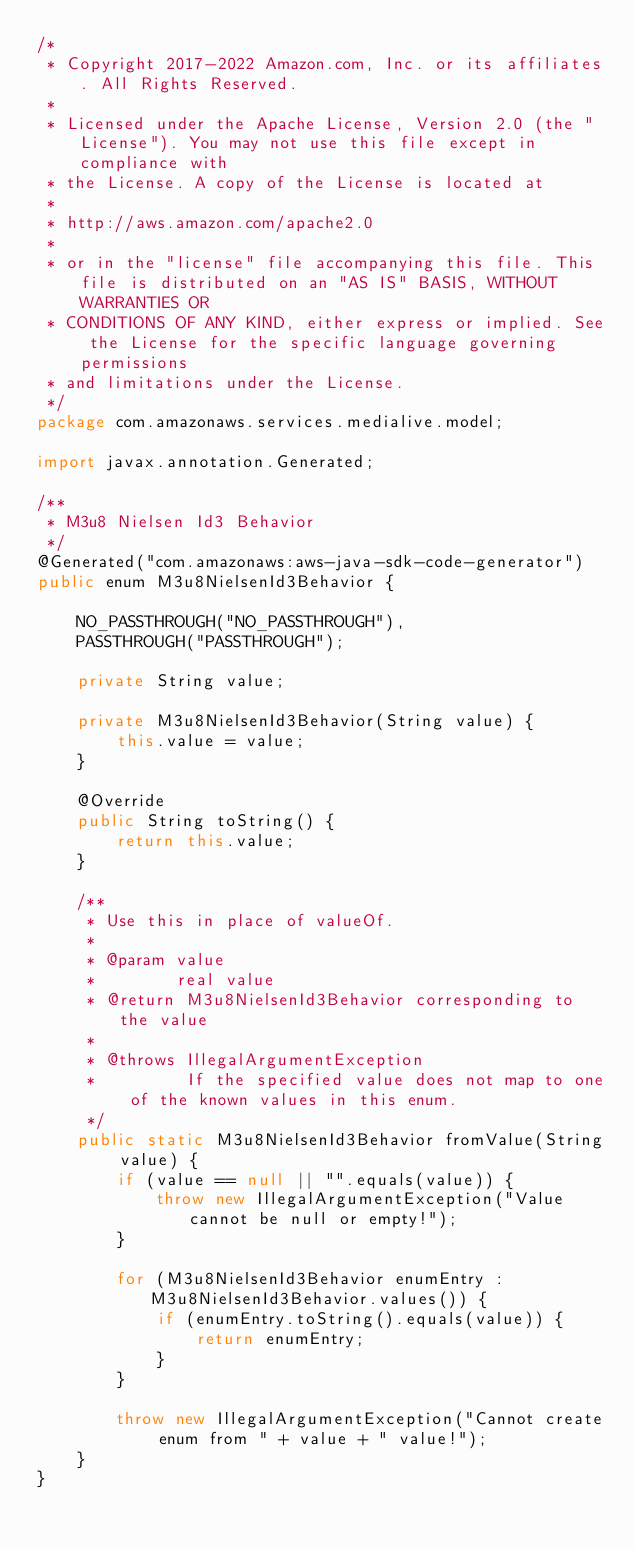<code> <loc_0><loc_0><loc_500><loc_500><_Java_>/*
 * Copyright 2017-2022 Amazon.com, Inc. or its affiliates. All Rights Reserved.
 * 
 * Licensed under the Apache License, Version 2.0 (the "License"). You may not use this file except in compliance with
 * the License. A copy of the License is located at
 * 
 * http://aws.amazon.com/apache2.0
 * 
 * or in the "license" file accompanying this file. This file is distributed on an "AS IS" BASIS, WITHOUT WARRANTIES OR
 * CONDITIONS OF ANY KIND, either express or implied. See the License for the specific language governing permissions
 * and limitations under the License.
 */
package com.amazonaws.services.medialive.model;

import javax.annotation.Generated;

/**
 * M3u8 Nielsen Id3 Behavior
 */
@Generated("com.amazonaws:aws-java-sdk-code-generator")
public enum M3u8NielsenId3Behavior {

    NO_PASSTHROUGH("NO_PASSTHROUGH"),
    PASSTHROUGH("PASSTHROUGH");

    private String value;

    private M3u8NielsenId3Behavior(String value) {
        this.value = value;
    }

    @Override
    public String toString() {
        return this.value;
    }

    /**
     * Use this in place of valueOf.
     *
     * @param value
     *        real value
     * @return M3u8NielsenId3Behavior corresponding to the value
     *
     * @throws IllegalArgumentException
     *         If the specified value does not map to one of the known values in this enum.
     */
    public static M3u8NielsenId3Behavior fromValue(String value) {
        if (value == null || "".equals(value)) {
            throw new IllegalArgumentException("Value cannot be null or empty!");
        }

        for (M3u8NielsenId3Behavior enumEntry : M3u8NielsenId3Behavior.values()) {
            if (enumEntry.toString().equals(value)) {
                return enumEntry;
            }
        }

        throw new IllegalArgumentException("Cannot create enum from " + value + " value!");
    }
}
</code> 